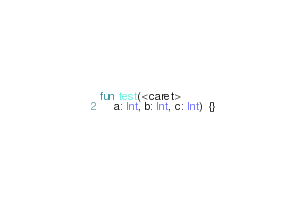Convert code to text. <code><loc_0><loc_0><loc_500><loc_500><_Kotlin_>fun test(<caret>
    a: Int, b: Int, c: Int) {}</code> 